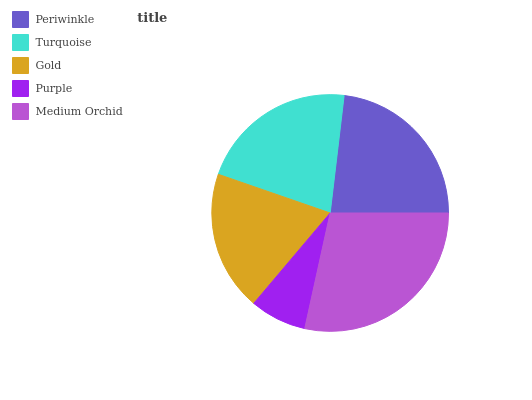Is Purple the minimum?
Answer yes or no. Yes. Is Medium Orchid the maximum?
Answer yes or no. Yes. Is Turquoise the minimum?
Answer yes or no. No. Is Turquoise the maximum?
Answer yes or no. No. Is Periwinkle greater than Turquoise?
Answer yes or no. Yes. Is Turquoise less than Periwinkle?
Answer yes or no. Yes. Is Turquoise greater than Periwinkle?
Answer yes or no. No. Is Periwinkle less than Turquoise?
Answer yes or no. No. Is Turquoise the high median?
Answer yes or no. Yes. Is Turquoise the low median?
Answer yes or no. Yes. Is Gold the high median?
Answer yes or no. No. Is Periwinkle the low median?
Answer yes or no. No. 